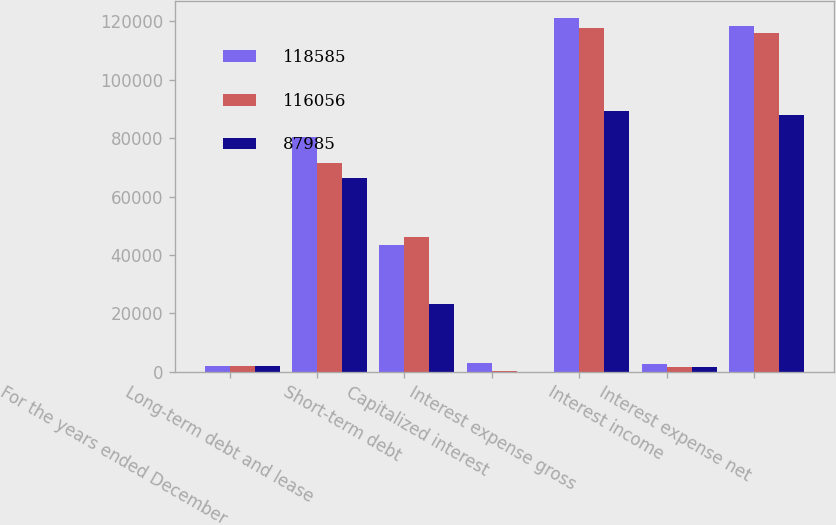Convert chart to OTSL. <chart><loc_0><loc_0><loc_500><loc_500><stacked_bar_chart><ecel><fcel>For the years ended December<fcel>Long-term debt and lease<fcel>Short-term debt<fcel>Capitalized interest<fcel>Interest expense gross<fcel>Interest income<fcel>Interest expense net<nl><fcel>118585<fcel>2007<fcel>80351<fcel>43485<fcel>2770<fcel>121066<fcel>2481<fcel>118585<nl><fcel>116056<fcel>2006<fcel>71546<fcel>46269<fcel>77<fcel>117738<fcel>1682<fcel>116056<nl><fcel>87985<fcel>2005<fcel>66324<fcel>23164<fcel>3<fcel>89485<fcel>1500<fcel>87985<nl></chart> 